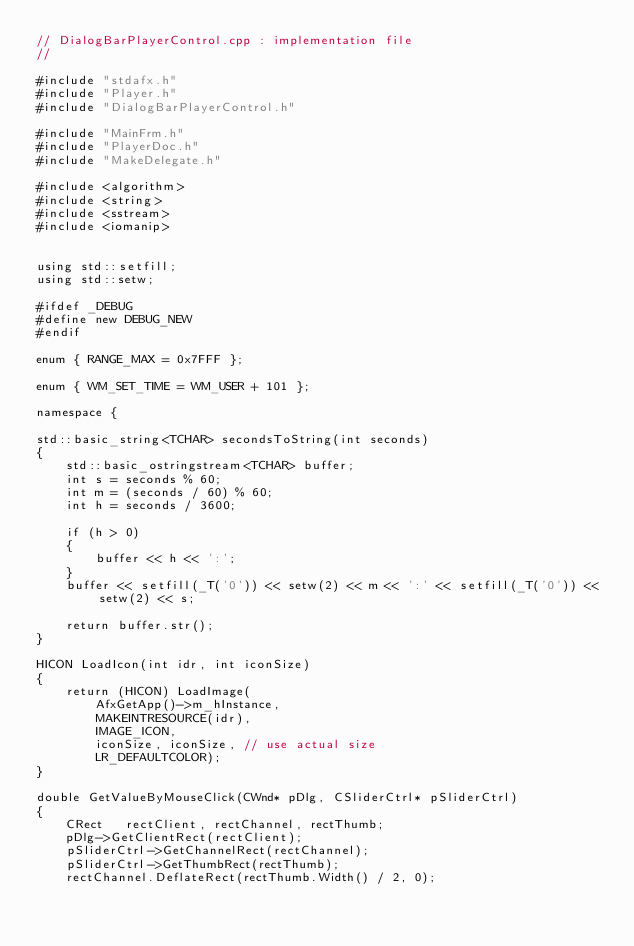<code> <loc_0><loc_0><loc_500><loc_500><_C++_>// DialogBarPlayerControl.cpp : implementation file
//

#include "stdafx.h"
#include "Player.h"
#include "DialogBarPlayerControl.h"

#include "MainFrm.h"
#include "PlayerDoc.h"
#include "MakeDelegate.h"

#include <algorithm>
#include <string>
#include <sstream>
#include <iomanip>


using std::setfill;
using std::setw;

#ifdef _DEBUG
#define new DEBUG_NEW
#endif

enum { RANGE_MAX = 0x7FFF };

enum { WM_SET_TIME = WM_USER + 101 };

namespace {

std::basic_string<TCHAR> secondsToString(int seconds)
{
    std::basic_ostringstream<TCHAR> buffer;
    int s = seconds % 60;
    int m = (seconds / 60) % 60;
    int h = seconds / 3600;

    if (h > 0)
    { 
        buffer << h << ':';
    }
    buffer << setfill(_T('0')) << setw(2) << m << ':' << setfill(_T('0')) << setw(2) << s;

    return buffer.str();
}

HICON LoadIcon(int idr, int iconSize)
{
    return (HICON) LoadImage(
        AfxGetApp()->m_hInstance,
        MAKEINTRESOURCE(idr),
        IMAGE_ICON,
        iconSize, iconSize, // use actual size
        LR_DEFAULTCOLOR);
}

double GetValueByMouseClick(CWnd* pDlg, CSliderCtrl* pSliderCtrl)
{
    CRect   rectClient, rectChannel, rectThumb;
    pDlg->GetClientRect(rectClient);
    pSliderCtrl->GetChannelRect(rectChannel);
    pSliderCtrl->GetThumbRect(rectThumb);
    rectChannel.DeflateRect(rectThumb.Width() / 2, 0);</code> 